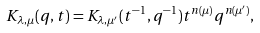<formula> <loc_0><loc_0><loc_500><loc_500>K _ { \lambda , \mu } ( q , t ) = K _ { \lambda , \mu ^ { \prime } } ( t ^ { - 1 } , q ^ { - 1 } ) t ^ { n ( \mu ) } q ^ { n ( \mu ^ { \prime } ) } ,</formula> 